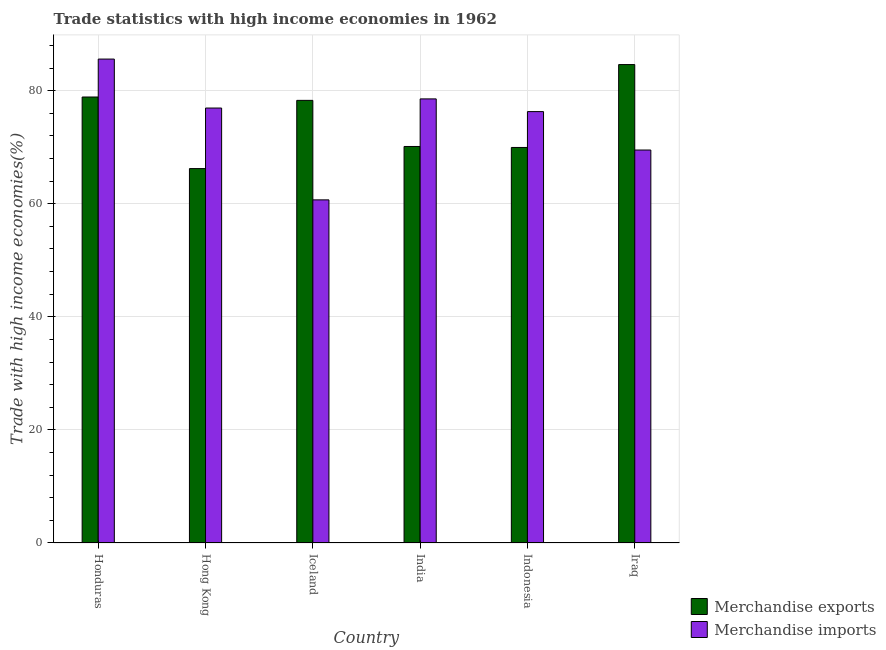How many different coloured bars are there?
Provide a short and direct response. 2. Are the number of bars per tick equal to the number of legend labels?
Your answer should be compact. Yes. Are the number of bars on each tick of the X-axis equal?
Provide a short and direct response. Yes. How many bars are there on the 2nd tick from the left?
Provide a succinct answer. 2. How many bars are there on the 2nd tick from the right?
Ensure brevity in your answer.  2. What is the merchandise exports in India?
Keep it short and to the point. 70.13. Across all countries, what is the maximum merchandise imports?
Offer a very short reply. 85.58. Across all countries, what is the minimum merchandise imports?
Ensure brevity in your answer.  60.68. In which country was the merchandise imports maximum?
Make the answer very short. Honduras. In which country was the merchandise imports minimum?
Make the answer very short. Iceland. What is the total merchandise exports in the graph?
Give a very brief answer. 448.06. What is the difference between the merchandise imports in Honduras and that in India?
Make the answer very short. 7.04. What is the difference between the merchandise exports in Iraq and the merchandise imports in India?
Your answer should be compact. 6.07. What is the average merchandise exports per country?
Give a very brief answer. 74.68. What is the difference between the merchandise exports and merchandise imports in Indonesia?
Offer a terse response. -6.34. In how many countries, is the merchandise imports greater than 20 %?
Offer a terse response. 6. What is the ratio of the merchandise exports in Iceland to that in India?
Your answer should be compact. 1.12. What is the difference between the highest and the second highest merchandise exports?
Keep it short and to the point. 5.74. What is the difference between the highest and the lowest merchandise imports?
Provide a succinct answer. 24.9. In how many countries, is the merchandise exports greater than the average merchandise exports taken over all countries?
Keep it short and to the point. 3. Is the sum of the merchandise imports in Honduras and India greater than the maximum merchandise exports across all countries?
Your answer should be compact. Yes. What does the 2nd bar from the right in Hong Kong represents?
Make the answer very short. Merchandise exports. How many countries are there in the graph?
Offer a very short reply. 6. What is the difference between two consecutive major ticks on the Y-axis?
Offer a terse response. 20. Does the graph contain grids?
Offer a very short reply. Yes. Where does the legend appear in the graph?
Offer a terse response. Bottom right. How are the legend labels stacked?
Ensure brevity in your answer.  Vertical. What is the title of the graph?
Give a very brief answer. Trade statistics with high income economies in 1962. What is the label or title of the Y-axis?
Provide a short and direct response. Trade with high income economies(%). What is the Trade with high income economies(%) in Merchandise exports in Honduras?
Make the answer very short. 78.88. What is the Trade with high income economies(%) of Merchandise imports in Honduras?
Your answer should be compact. 85.58. What is the Trade with high income economies(%) of Merchandise exports in Hong Kong?
Keep it short and to the point. 66.22. What is the Trade with high income economies(%) of Merchandise imports in Hong Kong?
Your answer should be very brief. 76.92. What is the Trade with high income economies(%) of Merchandise exports in Iceland?
Keep it short and to the point. 78.28. What is the Trade with high income economies(%) of Merchandise imports in Iceland?
Provide a short and direct response. 60.68. What is the Trade with high income economies(%) of Merchandise exports in India?
Give a very brief answer. 70.13. What is the Trade with high income economies(%) of Merchandise imports in India?
Keep it short and to the point. 78.54. What is the Trade with high income economies(%) in Merchandise exports in Indonesia?
Your response must be concise. 69.95. What is the Trade with high income economies(%) in Merchandise imports in Indonesia?
Keep it short and to the point. 76.29. What is the Trade with high income economies(%) of Merchandise exports in Iraq?
Provide a succinct answer. 84.61. What is the Trade with high income economies(%) of Merchandise imports in Iraq?
Your answer should be very brief. 69.5. Across all countries, what is the maximum Trade with high income economies(%) in Merchandise exports?
Your answer should be compact. 84.61. Across all countries, what is the maximum Trade with high income economies(%) in Merchandise imports?
Your answer should be compact. 85.58. Across all countries, what is the minimum Trade with high income economies(%) in Merchandise exports?
Your answer should be very brief. 66.22. Across all countries, what is the minimum Trade with high income economies(%) of Merchandise imports?
Offer a terse response. 60.68. What is the total Trade with high income economies(%) in Merchandise exports in the graph?
Ensure brevity in your answer.  448.06. What is the total Trade with high income economies(%) in Merchandise imports in the graph?
Keep it short and to the point. 447.52. What is the difference between the Trade with high income economies(%) of Merchandise exports in Honduras and that in Hong Kong?
Provide a succinct answer. 12.66. What is the difference between the Trade with high income economies(%) in Merchandise imports in Honduras and that in Hong Kong?
Provide a succinct answer. 8.66. What is the difference between the Trade with high income economies(%) of Merchandise exports in Honduras and that in Iceland?
Your answer should be compact. 0.59. What is the difference between the Trade with high income economies(%) of Merchandise imports in Honduras and that in Iceland?
Provide a short and direct response. 24.9. What is the difference between the Trade with high income economies(%) of Merchandise exports in Honduras and that in India?
Make the answer very short. 8.75. What is the difference between the Trade with high income economies(%) of Merchandise imports in Honduras and that in India?
Provide a short and direct response. 7.04. What is the difference between the Trade with high income economies(%) in Merchandise exports in Honduras and that in Indonesia?
Provide a succinct answer. 8.92. What is the difference between the Trade with high income economies(%) in Merchandise imports in Honduras and that in Indonesia?
Offer a terse response. 9.29. What is the difference between the Trade with high income economies(%) in Merchandise exports in Honduras and that in Iraq?
Provide a succinct answer. -5.74. What is the difference between the Trade with high income economies(%) in Merchandise imports in Honduras and that in Iraq?
Your answer should be compact. 16.09. What is the difference between the Trade with high income economies(%) in Merchandise exports in Hong Kong and that in Iceland?
Provide a succinct answer. -12.07. What is the difference between the Trade with high income economies(%) in Merchandise imports in Hong Kong and that in Iceland?
Offer a terse response. 16.24. What is the difference between the Trade with high income economies(%) of Merchandise exports in Hong Kong and that in India?
Ensure brevity in your answer.  -3.91. What is the difference between the Trade with high income economies(%) of Merchandise imports in Hong Kong and that in India?
Provide a short and direct response. -1.62. What is the difference between the Trade with high income economies(%) in Merchandise exports in Hong Kong and that in Indonesia?
Offer a terse response. -3.74. What is the difference between the Trade with high income economies(%) in Merchandise imports in Hong Kong and that in Indonesia?
Offer a very short reply. 0.63. What is the difference between the Trade with high income economies(%) in Merchandise exports in Hong Kong and that in Iraq?
Give a very brief answer. -18.39. What is the difference between the Trade with high income economies(%) in Merchandise imports in Hong Kong and that in Iraq?
Offer a very short reply. 7.43. What is the difference between the Trade with high income economies(%) of Merchandise exports in Iceland and that in India?
Make the answer very short. 8.16. What is the difference between the Trade with high income economies(%) of Merchandise imports in Iceland and that in India?
Your answer should be very brief. -17.86. What is the difference between the Trade with high income economies(%) in Merchandise exports in Iceland and that in Indonesia?
Your answer should be very brief. 8.33. What is the difference between the Trade with high income economies(%) in Merchandise imports in Iceland and that in Indonesia?
Provide a short and direct response. -15.61. What is the difference between the Trade with high income economies(%) in Merchandise exports in Iceland and that in Iraq?
Your answer should be compact. -6.33. What is the difference between the Trade with high income economies(%) in Merchandise imports in Iceland and that in Iraq?
Offer a terse response. -8.81. What is the difference between the Trade with high income economies(%) in Merchandise exports in India and that in Indonesia?
Your answer should be very brief. 0.17. What is the difference between the Trade with high income economies(%) of Merchandise imports in India and that in Indonesia?
Your response must be concise. 2.25. What is the difference between the Trade with high income economies(%) of Merchandise exports in India and that in Iraq?
Your answer should be very brief. -14.48. What is the difference between the Trade with high income economies(%) in Merchandise imports in India and that in Iraq?
Ensure brevity in your answer.  9.04. What is the difference between the Trade with high income economies(%) in Merchandise exports in Indonesia and that in Iraq?
Your answer should be very brief. -14.66. What is the difference between the Trade with high income economies(%) of Merchandise imports in Indonesia and that in Iraq?
Your answer should be very brief. 6.8. What is the difference between the Trade with high income economies(%) in Merchandise exports in Honduras and the Trade with high income economies(%) in Merchandise imports in Hong Kong?
Keep it short and to the point. 1.95. What is the difference between the Trade with high income economies(%) in Merchandise exports in Honduras and the Trade with high income economies(%) in Merchandise imports in Iceland?
Give a very brief answer. 18.19. What is the difference between the Trade with high income economies(%) in Merchandise exports in Honduras and the Trade with high income economies(%) in Merchandise imports in India?
Offer a very short reply. 0.34. What is the difference between the Trade with high income economies(%) of Merchandise exports in Honduras and the Trade with high income economies(%) of Merchandise imports in Indonesia?
Make the answer very short. 2.58. What is the difference between the Trade with high income economies(%) in Merchandise exports in Honduras and the Trade with high income economies(%) in Merchandise imports in Iraq?
Your answer should be compact. 9.38. What is the difference between the Trade with high income economies(%) of Merchandise exports in Hong Kong and the Trade with high income economies(%) of Merchandise imports in Iceland?
Provide a succinct answer. 5.53. What is the difference between the Trade with high income economies(%) of Merchandise exports in Hong Kong and the Trade with high income economies(%) of Merchandise imports in India?
Offer a terse response. -12.32. What is the difference between the Trade with high income economies(%) in Merchandise exports in Hong Kong and the Trade with high income economies(%) in Merchandise imports in Indonesia?
Provide a succinct answer. -10.08. What is the difference between the Trade with high income economies(%) in Merchandise exports in Hong Kong and the Trade with high income economies(%) in Merchandise imports in Iraq?
Make the answer very short. -3.28. What is the difference between the Trade with high income economies(%) of Merchandise exports in Iceland and the Trade with high income economies(%) of Merchandise imports in India?
Your answer should be compact. -0.26. What is the difference between the Trade with high income economies(%) in Merchandise exports in Iceland and the Trade with high income economies(%) in Merchandise imports in Indonesia?
Give a very brief answer. 1.99. What is the difference between the Trade with high income economies(%) in Merchandise exports in Iceland and the Trade with high income economies(%) in Merchandise imports in Iraq?
Your answer should be very brief. 8.78. What is the difference between the Trade with high income economies(%) of Merchandise exports in India and the Trade with high income economies(%) of Merchandise imports in Indonesia?
Make the answer very short. -6.17. What is the difference between the Trade with high income economies(%) of Merchandise exports in India and the Trade with high income economies(%) of Merchandise imports in Iraq?
Offer a terse response. 0.63. What is the difference between the Trade with high income economies(%) in Merchandise exports in Indonesia and the Trade with high income economies(%) in Merchandise imports in Iraq?
Keep it short and to the point. 0.45. What is the average Trade with high income economies(%) in Merchandise exports per country?
Keep it short and to the point. 74.68. What is the average Trade with high income economies(%) in Merchandise imports per country?
Your response must be concise. 74.59. What is the difference between the Trade with high income economies(%) in Merchandise exports and Trade with high income economies(%) in Merchandise imports in Honduras?
Your answer should be very brief. -6.71. What is the difference between the Trade with high income economies(%) in Merchandise exports and Trade with high income economies(%) in Merchandise imports in Hong Kong?
Provide a succinct answer. -10.71. What is the difference between the Trade with high income economies(%) in Merchandise exports and Trade with high income economies(%) in Merchandise imports in Iceland?
Your response must be concise. 17.6. What is the difference between the Trade with high income economies(%) of Merchandise exports and Trade with high income economies(%) of Merchandise imports in India?
Offer a terse response. -8.41. What is the difference between the Trade with high income economies(%) in Merchandise exports and Trade with high income economies(%) in Merchandise imports in Indonesia?
Keep it short and to the point. -6.34. What is the difference between the Trade with high income economies(%) of Merchandise exports and Trade with high income economies(%) of Merchandise imports in Iraq?
Ensure brevity in your answer.  15.11. What is the ratio of the Trade with high income economies(%) of Merchandise exports in Honduras to that in Hong Kong?
Offer a terse response. 1.19. What is the ratio of the Trade with high income economies(%) of Merchandise imports in Honduras to that in Hong Kong?
Provide a succinct answer. 1.11. What is the ratio of the Trade with high income economies(%) in Merchandise exports in Honduras to that in Iceland?
Your answer should be compact. 1.01. What is the ratio of the Trade with high income economies(%) of Merchandise imports in Honduras to that in Iceland?
Your answer should be very brief. 1.41. What is the ratio of the Trade with high income economies(%) in Merchandise exports in Honduras to that in India?
Offer a terse response. 1.12. What is the ratio of the Trade with high income economies(%) of Merchandise imports in Honduras to that in India?
Provide a short and direct response. 1.09. What is the ratio of the Trade with high income economies(%) in Merchandise exports in Honduras to that in Indonesia?
Give a very brief answer. 1.13. What is the ratio of the Trade with high income economies(%) in Merchandise imports in Honduras to that in Indonesia?
Make the answer very short. 1.12. What is the ratio of the Trade with high income economies(%) of Merchandise exports in Honduras to that in Iraq?
Your answer should be compact. 0.93. What is the ratio of the Trade with high income economies(%) of Merchandise imports in Honduras to that in Iraq?
Offer a very short reply. 1.23. What is the ratio of the Trade with high income economies(%) of Merchandise exports in Hong Kong to that in Iceland?
Keep it short and to the point. 0.85. What is the ratio of the Trade with high income economies(%) in Merchandise imports in Hong Kong to that in Iceland?
Your answer should be compact. 1.27. What is the ratio of the Trade with high income economies(%) in Merchandise exports in Hong Kong to that in India?
Your response must be concise. 0.94. What is the ratio of the Trade with high income economies(%) in Merchandise imports in Hong Kong to that in India?
Offer a very short reply. 0.98. What is the ratio of the Trade with high income economies(%) of Merchandise exports in Hong Kong to that in Indonesia?
Give a very brief answer. 0.95. What is the ratio of the Trade with high income economies(%) of Merchandise imports in Hong Kong to that in Indonesia?
Provide a succinct answer. 1.01. What is the ratio of the Trade with high income economies(%) of Merchandise exports in Hong Kong to that in Iraq?
Make the answer very short. 0.78. What is the ratio of the Trade with high income economies(%) of Merchandise imports in Hong Kong to that in Iraq?
Offer a very short reply. 1.11. What is the ratio of the Trade with high income economies(%) of Merchandise exports in Iceland to that in India?
Your response must be concise. 1.12. What is the ratio of the Trade with high income economies(%) of Merchandise imports in Iceland to that in India?
Keep it short and to the point. 0.77. What is the ratio of the Trade with high income economies(%) of Merchandise exports in Iceland to that in Indonesia?
Your response must be concise. 1.12. What is the ratio of the Trade with high income economies(%) in Merchandise imports in Iceland to that in Indonesia?
Your answer should be compact. 0.8. What is the ratio of the Trade with high income economies(%) of Merchandise exports in Iceland to that in Iraq?
Your answer should be very brief. 0.93. What is the ratio of the Trade with high income economies(%) of Merchandise imports in Iceland to that in Iraq?
Give a very brief answer. 0.87. What is the ratio of the Trade with high income economies(%) of Merchandise imports in India to that in Indonesia?
Provide a succinct answer. 1.03. What is the ratio of the Trade with high income economies(%) of Merchandise exports in India to that in Iraq?
Make the answer very short. 0.83. What is the ratio of the Trade with high income economies(%) in Merchandise imports in India to that in Iraq?
Give a very brief answer. 1.13. What is the ratio of the Trade with high income economies(%) of Merchandise exports in Indonesia to that in Iraq?
Provide a succinct answer. 0.83. What is the ratio of the Trade with high income economies(%) in Merchandise imports in Indonesia to that in Iraq?
Your response must be concise. 1.1. What is the difference between the highest and the second highest Trade with high income economies(%) in Merchandise exports?
Give a very brief answer. 5.74. What is the difference between the highest and the second highest Trade with high income economies(%) of Merchandise imports?
Make the answer very short. 7.04. What is the difference between the highest and the lowest Trade with high income economies(%) of Merchandise exports?
Provide a succinct answer. 18.39. What is the difference between the highest and the lowest Trade with high income economies(%) of Merchandise imports?
Make the answer very short. 24.9. 